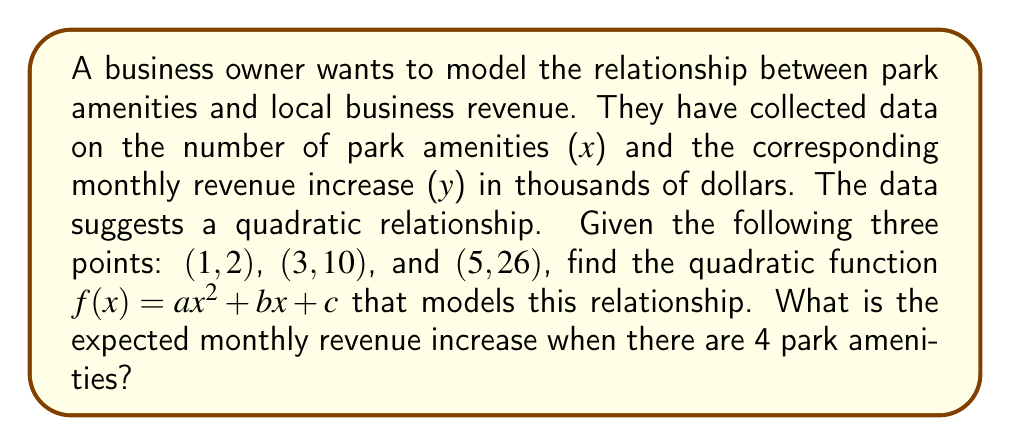Solve this math problem. 1) We need to find the quadratic function $f(x) = ax^2 + bx + c$ that passes through the given points.

2) Substitute each point into the general form of the quadratic equation:
   (1, 2):  $2 = a(1)^2 + b(1) + c$
   (3, 10): $10 = a(3)^2 + b(3) + c$
   (5, 26): $26 = a(5)^2 + b(5) + c$

3) Simplify:
   $2 = a + b + c$     (Equation 1)
   $10 = 9a + 3b + c$  (Equation 2)
   $26 = 25a + 5b + c$ (Equation 3)

4) Subtract Equation 1 from Equation 2:
   $8 = 8a + 2b$
   $4 = 4a + b$        (Equation 4)

5) Subtract Equation 2 from Equation 3:
   $16 = 16a + 2b$
   $8 = 8a + b$        (Equation 5)

6) Subtract Equation 4 from Equation 5:
   $4 = 4a$
   $a = 1$

7) Substitute $a = 1$ into Equation 4:
   $4 = 4(1) + b$
   $b = 0$

8) Substitute $a = 1$ and $b = 0$ into Equation 1:
   $2 = 1 + 0 + c$
   $c = 1$

9) Therefore, the quadratic function is $f(x) = x^2 + 1$

10) To find the expected revenue increase for 4 amenities, substitute $x = 4$:
    $f(4) = 4^2 + 1 = 16 + 1 = 17$
Answer: $17,000 